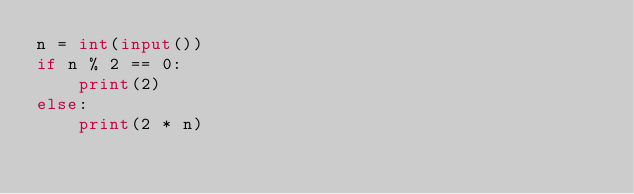Convert code to text. <code><loc_0><loc_0><loc_500><loc_500><_Python_>n = int(input())
if n % 2 == 0:
    print(2)
else:
    print(2 * n)</code> 